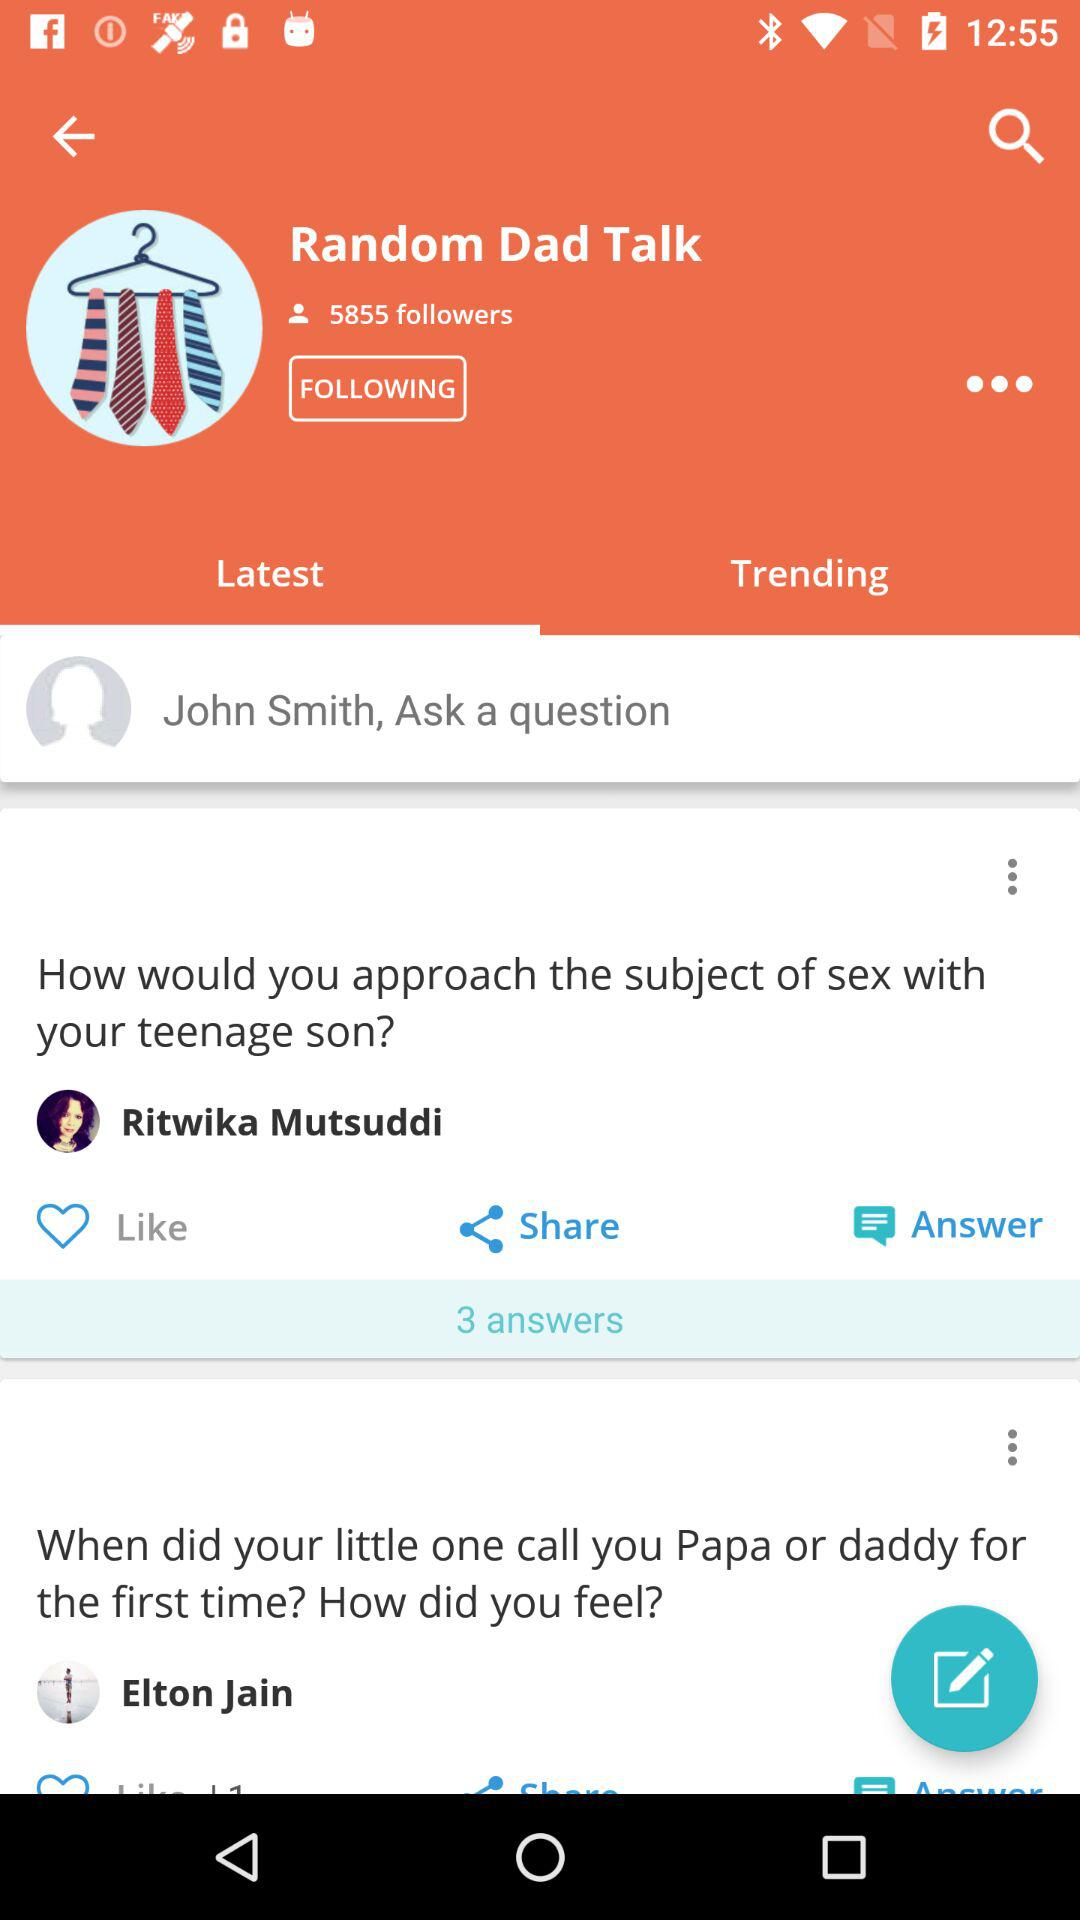Who asked the question? The questions were asked by Ritwika Mutsuddi and Elton Jain. 